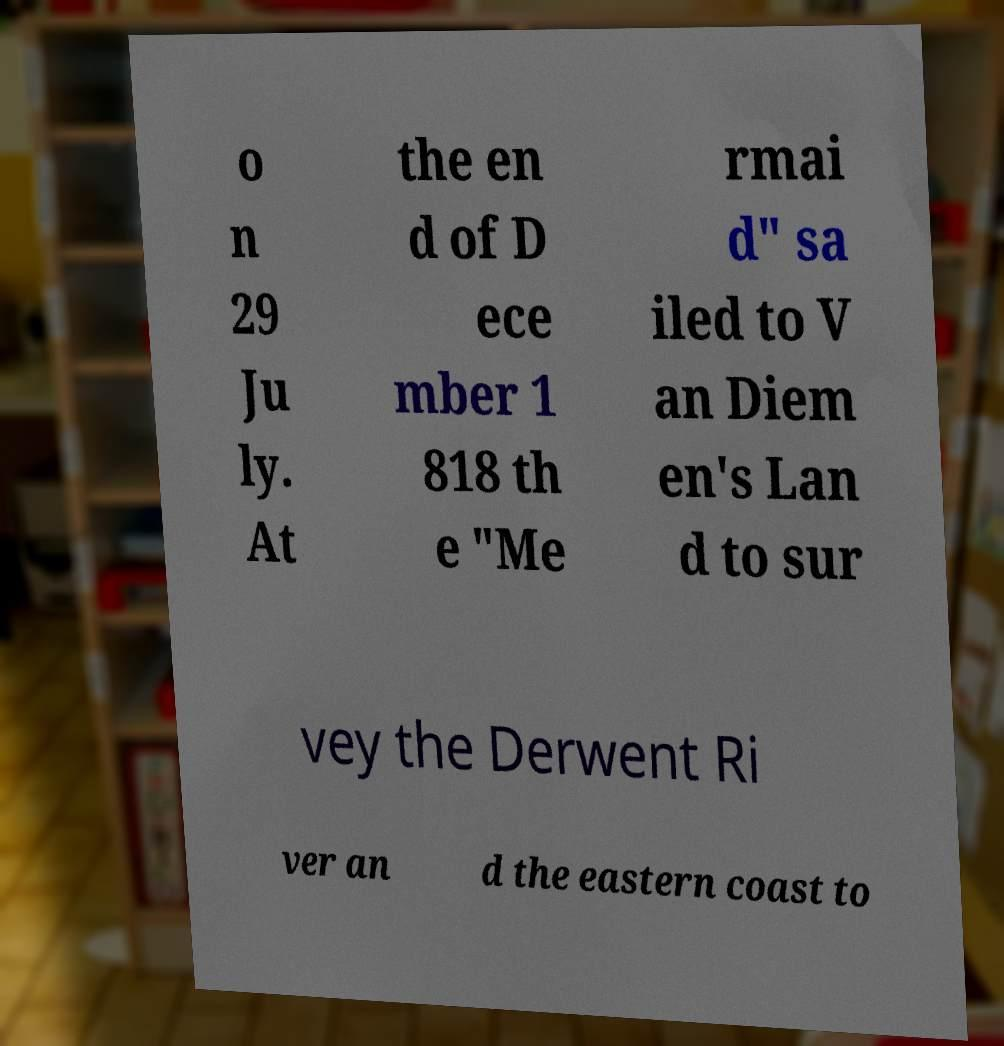There's text embedded in this image that I need extracted. Can you transcribe it verbatim? o n 29 Ju ly. At the en d of D ece mber 1 818 th e "Me rmai d" sa iled to V an Diem en's Lan d to sur vey the Derwent Ri ver an d the eastern coast to 